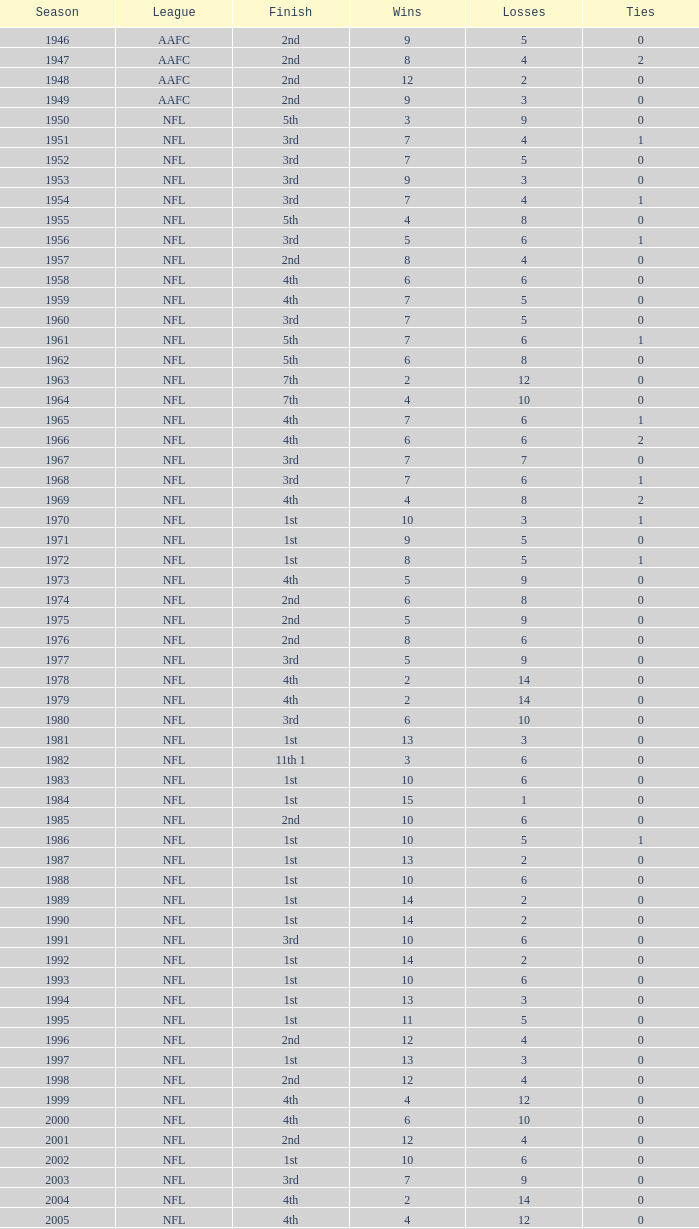What is the lowest number of ties in the NFL, with less than 2 losses and less than 15 wins? None. 